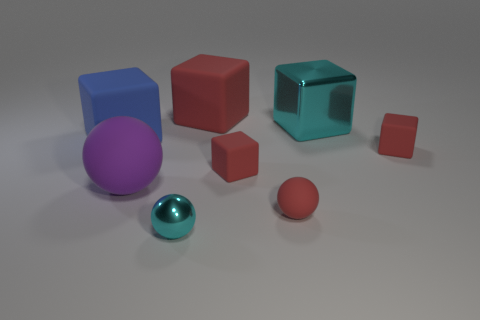How big is the blue cube?
Provide a succinct answer. Large. The big rubber object that is right of the cyan shiny object that is in front of the tiny rubber sphere is what color?
Offer a very short reply. Red. How many things are to the left of the large red block and in front of the big blue object?
Ensure brevity in your answer.  2. Are there more tiny red rubber cubes than large gray rubber cylinders?
Give a very brief answer. Yes. What is the material of the blue object?
Keep it short and to the point. Rubber. There is a large thing that is to the left of the purple rubber thing; what number of tiny red rubber objects are in front of it?
Your answer should be very brief. 3. There is a large shiny block; does it have the same color as the rubber sphere that is left of the cyan metal ball?
Keep it short and to the point. No. What color is the other ball that is the same size as the metal sphere?
Provide a short and direct response. Red. Is there another red matte thing of the same shape as the large red thing?
Your answer should be very brief. Yes. Are there fewer big blue things than large gray rubber things?
Make the answer very short. No. 